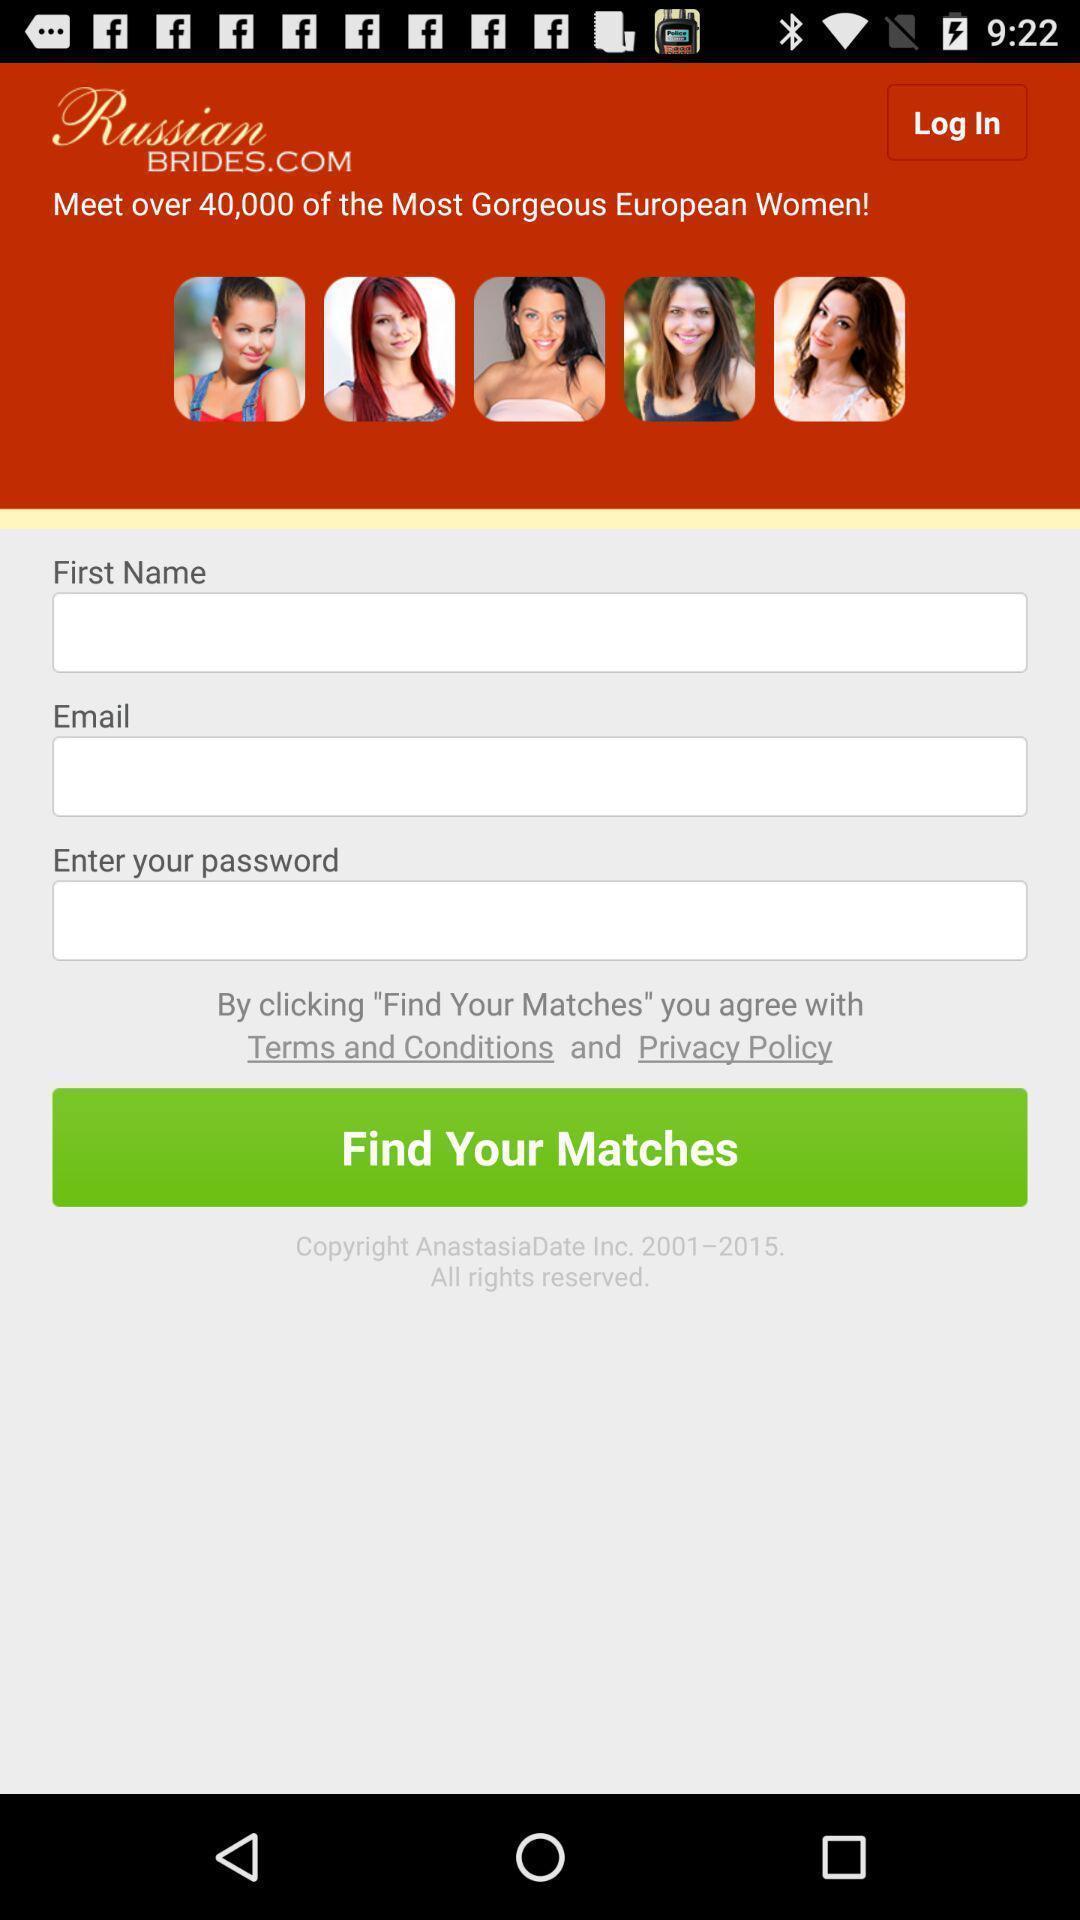Give me a summary of this screen capture. Welcome page of a social app. 